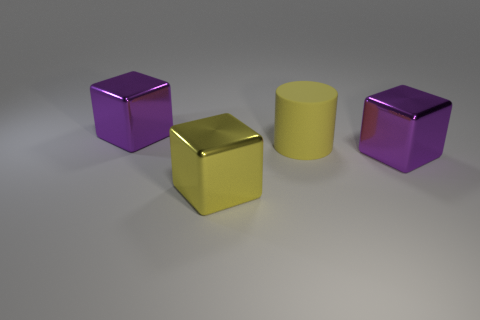Subtract all big yellow cubes. How many cubes are left? 2 Add 3 yellow rubber objects. How many objects exist? 7 Subtract all cubes. How many objects are left? 1 Subtract all small gray matte things. Subtract all cubes. How many objects are left? 1 Add 3 large metallic things. How many large metallic things are left? 6 Add 3 large yellow blocks. How many large yellow blocks exist? 4 Subtract 0 brown blocks. How many objects are left? 4 Subtract all blue cubes. Subtract all brown balls. How many cubes are left? 3 